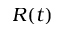Convert formula to latex. <formula><loc_0><loc_0><loc_500><loc_500>R ( t )</formula> 